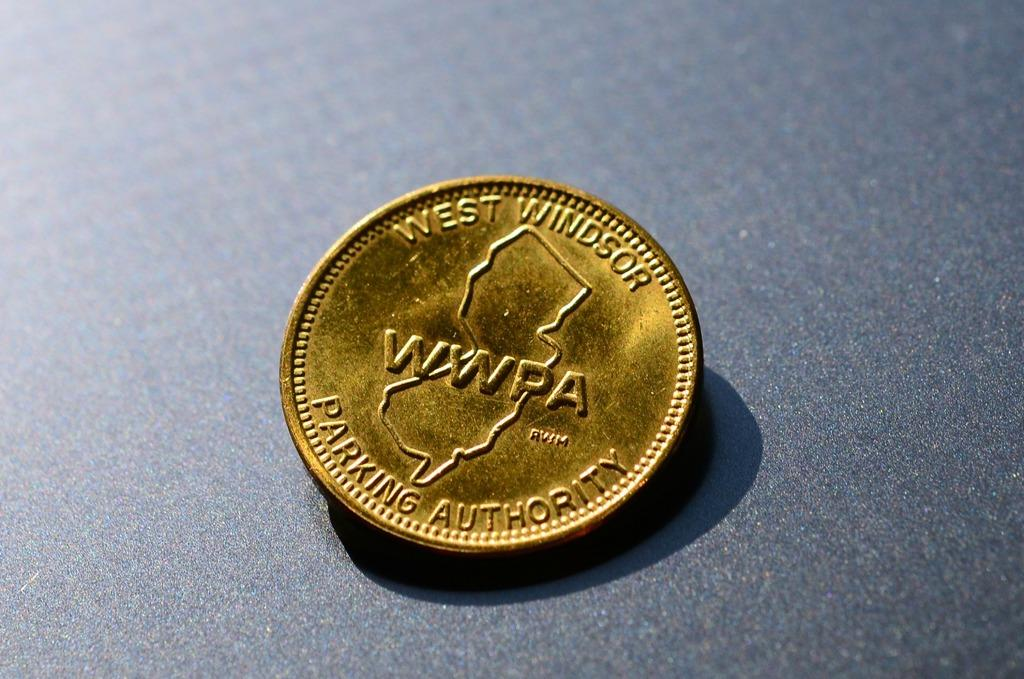<image>
Share a concise interpretation of the image provided. a gold coin that says 'west windsor parking authority' on it 